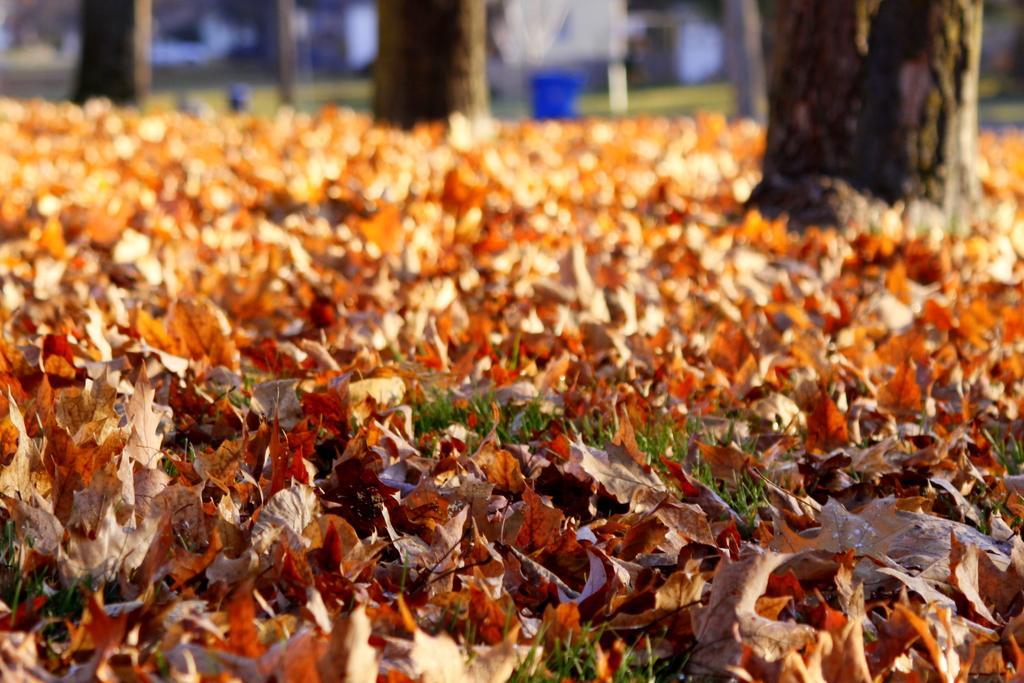Describe this image in one or two sentences. There are dried leaves and grasses on the ground. In the back it is blurred and there are tree trunks. 